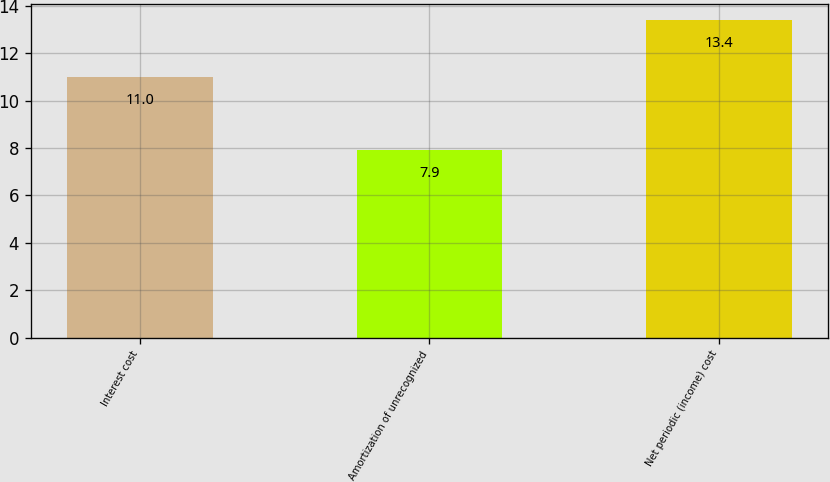<chart> <loc_0><loc_0><loc_500><loc_500><bar_chart><fcel>Interest cost<fcel>Amortization of unrecognized<fcel>Net periodic (income) cost<nl><fcel>11<fcel>7.9<fcel>13.4<nl></chart> 